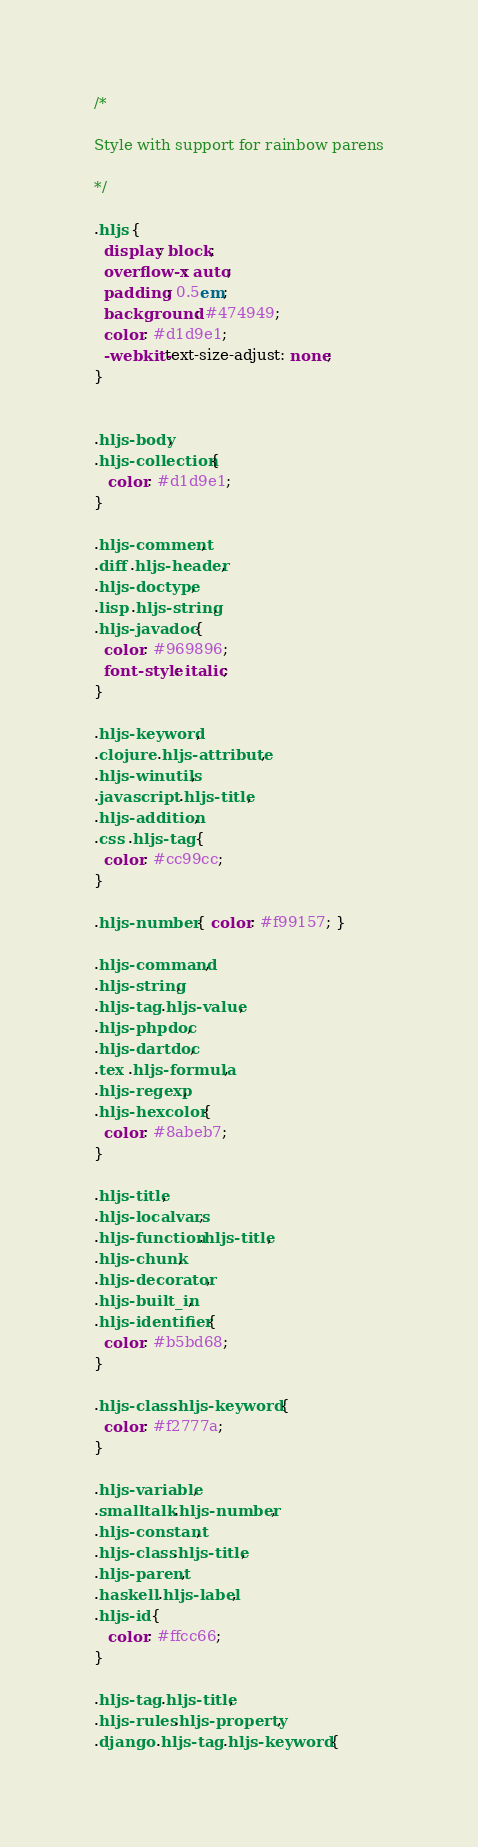Convert code to text. <code><loc_0><loc_0><loc_500><loc_500><_CSS_>/*

Style with support for rainbow parens

*/

.hljs {
  display: block;
  overflow-x: auto;
  padding: 0.5em;
  background: #474949;
  color: #d1d9e1;
  -webkit-text-size-adjust: none;
}


.hljs-body,
.hljs-collection {
   color: #d1d9e1;
}

.hljs-comment,
.diff .hljs-header,
.hljs-doctype,
.lisp .hljs-string,
.hljs-javadoc {
  color: #969896;
  font-style: italic;
}

.hljs-keyword,
.clojure .hljs-attribute,
.hljs-winutils,
.javascript .hljs-title,
.hljs-addition,
.css .hljs-tag {
  color: #cc99cc;
}

.hljs-number { color: #f99157; }

.hljs-command,
.hljs-string,
.hljs-tag .hljs-value,
.hljs-phpdoc,
.hljs-dartdoc,
.tex .hljs-formula,
.hljs-regexp,
.hljs-hexcolor {
  color: #8abeb7;
}

.hljs-title,
.hljs-localvars,
.hljs-function .hljs-title,
.hljs-chunk,
.hljs-decorator,
.hljs-built_in,
.hljs-identifier {
  color: #b5bd68;
}

.hljs-class .hljs-keyword {
  color: #f2777a;
}

.hljs-variable,
.smalltalk .hljs-number,
.hljs-constant,
.hljs-class .hljs-title,
.hljs-parent,
.haskell .hljs-label,
.hljs-id {
   color: #ffcc66;
}

.hljs-tag .hljs-title,
.hljs-rules .hljs-property,
.django .hljs-tag .hljs-keyword {</code> 